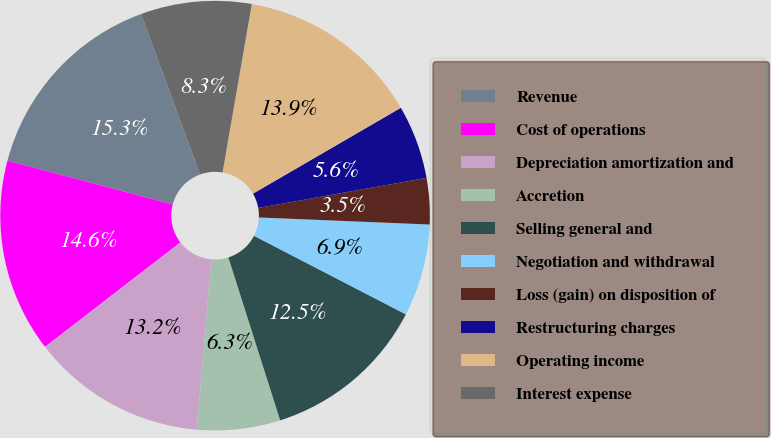<chart> <loc_0><loc_0><loc_500><loc_500><pie_chart><fcel>Revenue<fcel>Cost of operations<fcel>Depreciation amortization and<fcel>Accretion<fcel>Selling general and<fcel>Negotiation and withdrawal<fcel>Loss (gain) on disposition of<fcel>Restructuring charges<fcel>Operating income<fcel>Interest expense<nl><fcel>15.28%<fcel>14.58%<fcel>13.19%<fcel>6.25%<fcel>12.5%<fcel>6.94%<fcel>3.47%<fcel>5.56%<fcel>13.89%<fcel>8.33%<nl></chart> 